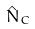Convert formula to latex. <formula><loc_0><loc_0><loc_500><loc_500>\hat { N } _ { C }</formula> 